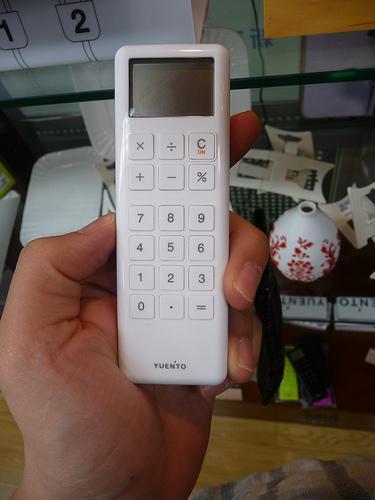How many calculators are there?
Give a very brief answer. 1. 